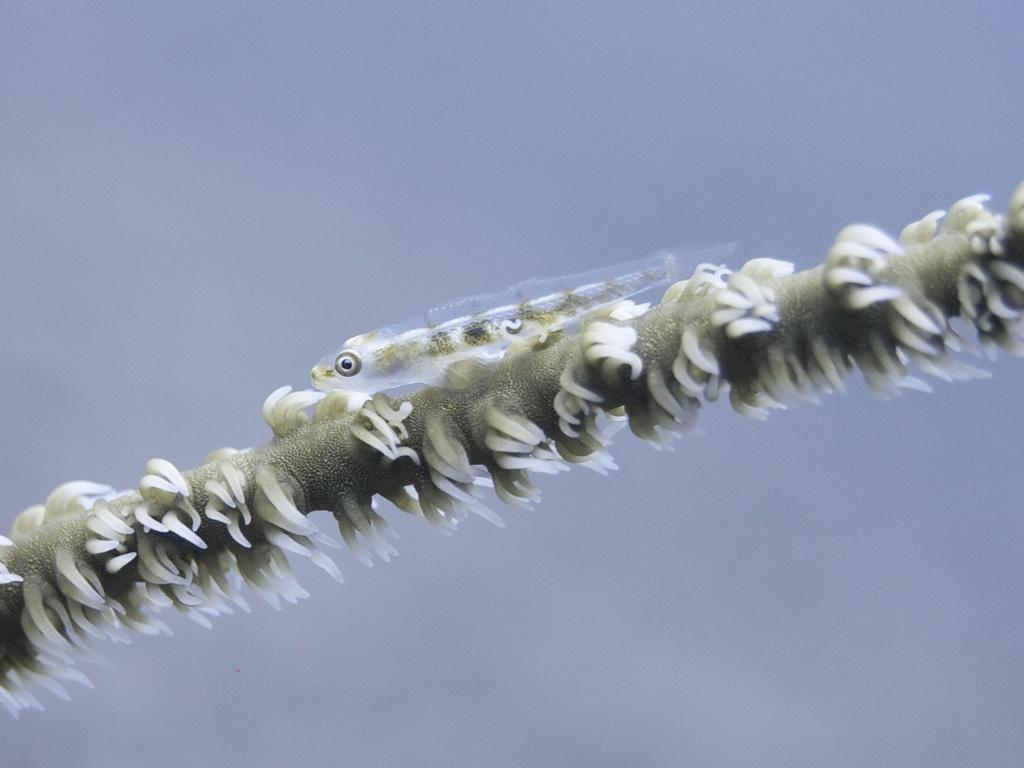What type of animal is in the image? There is a fish in the image. What is the fish resting on or surrounded by? The fish is on algae. What type of print can be seen on the sky in the image? There is no sky or print present in the image; it features a fish on algae. Can you spot a squirrel in the image? There is no squirrel present in the image. 